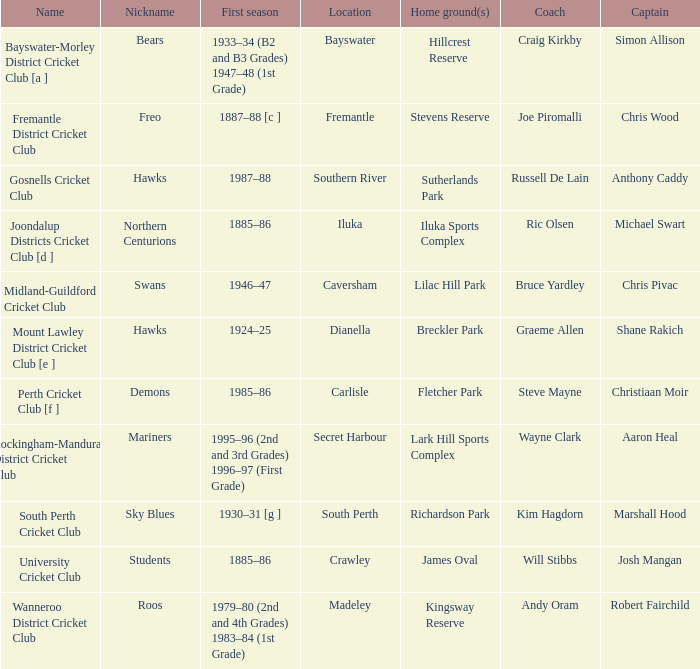For location Caversham, what is the name of the captain? Chris Pivac. 